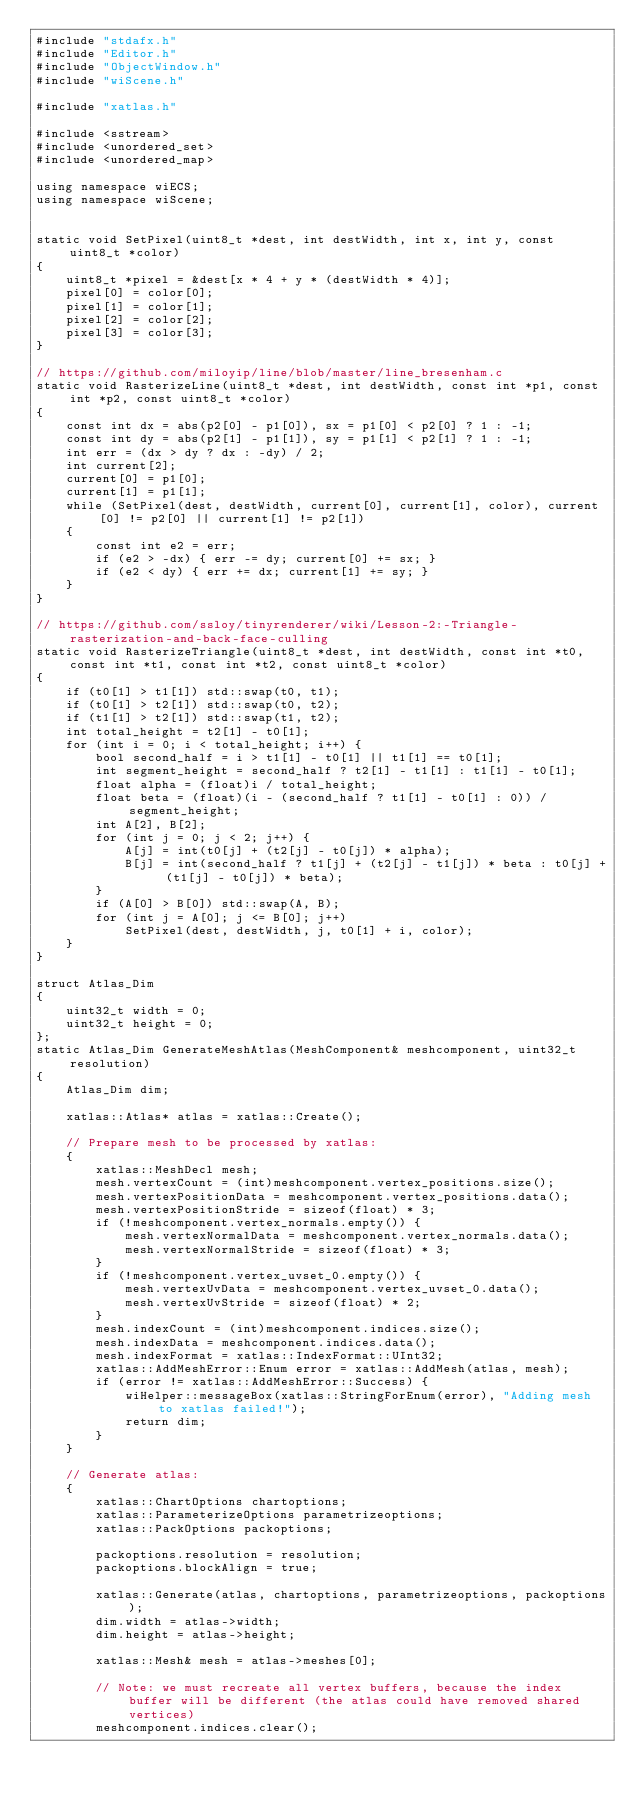<code> <loc_0><loc_0><loc_500><loc_500><_C++_>#include "stdafx.h"
#include "Editor.h"
#include "ObjectWindow.h"
#include "wiScene.h"

#include "xatlas.h"

#include <sstream>
#include <unordered_set>
#include <unordered_map>

using namespace wiECS;
using namespace wiScene;


static void SetPixel(uint8_t *dest, int destWidth, int x, int y, const uint8_t *color)
{
	uint8_t *pixel = &dest[x * 4 + y * (destWidth * 4)];
	pixel[0] = color[0];
	pixel[1] = color[1];
	pixel[2] = color[2];
	pixel[3] = color[3];
}

// https://github.com/miloyip/line/blob/master/line_bresenham.c
static void RasterizeLine(uint8_t *dest, int destWidth, const int *p1, const int *p2, const uint8_t *color)
{
	const int dx = abs(p2[0] - p1[0]), sx = p1[0] < p2[0] ? 1 : -1;
	const int dy = abs(p2[1] - p1[1]), sy = p1[1] < p2[1] ? 1 : -1;
	int err = (dx > dy ? dx : -dy) / 2;
	int current[2];
	current[0] = p1[0];
	current[1] = p1[1];
	while (SetPixel(dest, destWidth, current[0], current[1], color), current[0] != p2[0] || current[1] != p2[1])
	{
		const int e2 = err;
		if (e2 > -dx) { err -= dy; current[0] += sx; }
		if (e2 < dy) { err += dx; current[1] += sy; }
	}
}

// https://github.com/ssloy/tinyrenderer/wiki/Lesson-2:-Triangle-rasterization-and-back-face-culling
static void RasterizeTriangle(uint8_t *dest, int destWidth, const int *t0, const int *t1, const int *t2, const uint8_t *color)
{
	if (t0[1] > t1[1]) std::swap(t0, t1);
	if (t0[1] > t2[1]) std::swap(t0, t2);
	if (t1[1] > t2[1]) std::swap(t1, t2);
	int total_height = t2[1] - t0[1];
	for (int i = 0; i < total_height; i++) {
		bool second_half = i > t1[1] - t0[1] || t1[1] == t0[1];
		int segment_height = second_half ? t2[1] - t1[1] : t1[1] - t0[1];
		float alpha = (float)i / total_height;
		float beta = (float)(i - (second_half ? t1[1] - t0[1] : 0)) / segment_height;
		int A[2], B[2];
		for (int j = 0; j < 2; j++) {
			A[j] = int(t0[j] + (t2[j] - t0[j]) * alpha);
			B[j] = int(second_half ? t1[j] + (t2[j] - t1[j]) * beta : t0[j] + (t1[j] - t0[j]) * beta);
		}
		if (A[0] > B[0]) std::swap(A, B);
		for (int j = A[0]; j <= B[0]; j++)
			SetPixel(dest, destWidth, j, t0[1] + i, color);
	}
}

struct Atlas_Dim
{
	uint32_t width = 0;
	uint32_t height = 0;
};
static Atlas_Dim GenerateMeshAtlas(MeshComponent& meshcomponent, uint32_t resolution)
{
	Atlas_Dim dim;

	xatlas::Atlas* atlas = xatlas::Create();

	// Prepare mesh to be processed by xatlas:
	{
		xatlas::MeshDecl mesh;
		mesh.vertexCount = (int)meshcomponent.vertex_positions.size();
		mesh.vertexPositionData = meshcomponent.vertex_positions.data();
		mesh.vertexPositionStride = sizeof(float) * 3;
		if (!meshcomponent.vertex_normals.empty()) {
			mesh.vertexNormalData = meshcomponent.vertex_normals.data();
			mesh.vertexNormalStride = sizeof(float) * 3;
		}
		if (!meshcomponent.vertex_uvset_0.empty()) {
			mesh.vertexUvData = meshcomponent.vertex_uvset_0.data();
			mesh.vertexUvStride = sizeof(float) * 2;
		}
		mesh.indexCount = (int)meshcomponent.indices.size();
		mesh.indexData = meshcomponent.indices.data();
		mesh.indexFormat = xatlas::IndexFormat::UInt32;
		xatlas::AddMeshError::Enum error = xatlas::AddMesh(atlas, mesh);
		if (error != xatlas::AddMeshError::Success) {
			wiHelper::messageBox(xatlas::StringForEnum(error), "Adding mesh to xatlas failed!");
			return dim;
		}
	}

	// Generate atlas:
	{
		xatlas::ChartOptions chartoptions;
		xatlas::ParameterizeOptions parametrizeoptions;
		xatlas::PackOptions packoptions;

		packoptions.resolution = resolution;
		packoptions.blockAlign = true;

		xatlas::Generate(atlas, chartoptions, parametrizeoptions, packoptions);
		dim.width = atlas->width;
		dim.height = atlas->height;

		xatlas::Mesh& mesh = atlas->meshes[0];

		// Note: we must recreate all vertex buffers, because the index buffer will be different (the atlas could have removed shared vertices)
		meshcomponent.indices.clear();</code> 